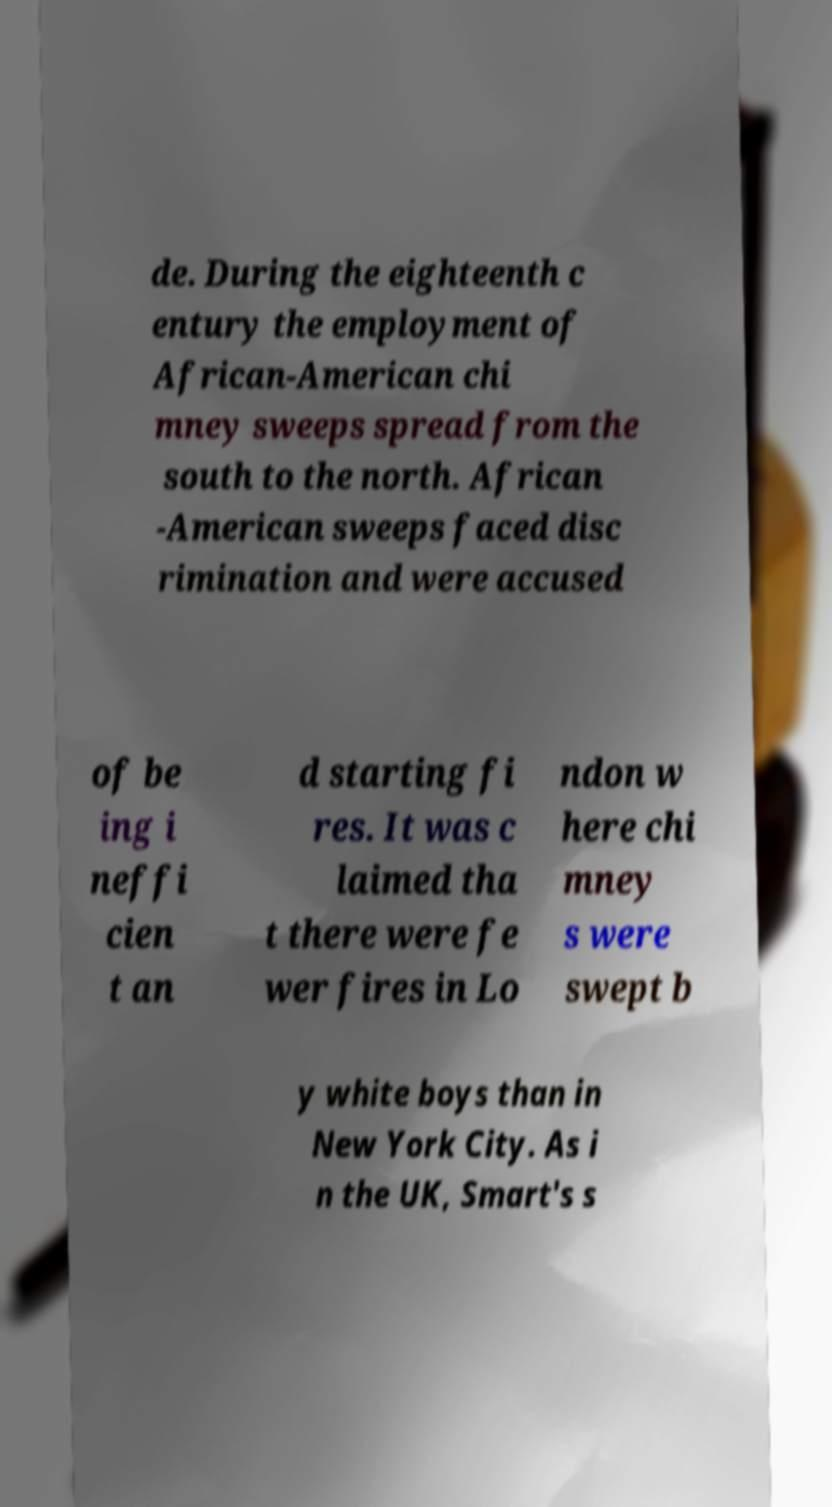There's text embedded in this image that I need extracted. Can you transcribe it verbatim? de. During the eighteenth c entury the employment of African-American chi mney sweeps spread from the south to the north. African -American sweeps faced disc rimination and were accused of be ing i neffi cien t an d starting fi res. It was c laimed tha t there were fe wer fires in Lo ndon w here chi mney s were swept b y white boys than in New York City. As i n the UK, Smart's s 